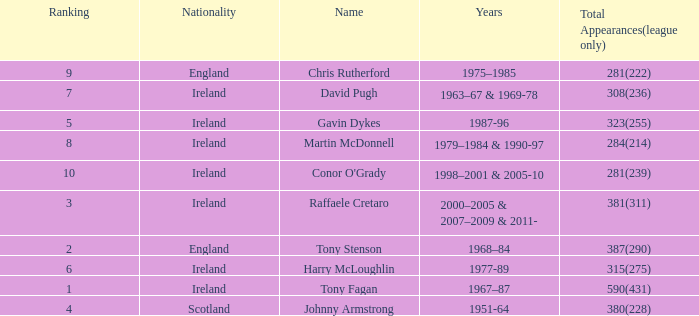What nationality has a ranking less than 7 with tony stenson as the name? England. 